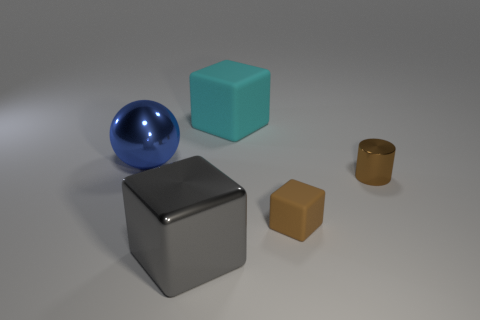Add 5 matte objects. How many objects exist? 10 Subtract all blocks. How many objects are left? 2 Subtract all small brown rubber things. Subtract all large metal blocks. How many objects are left? 3 Add 3 cylinders. How many cylinders are left? 4 Add 2 gray rubber cylinders. How many gray rubber cylinders exist? 2 Subtract 1 gray cubes. How many objects are left? 4 